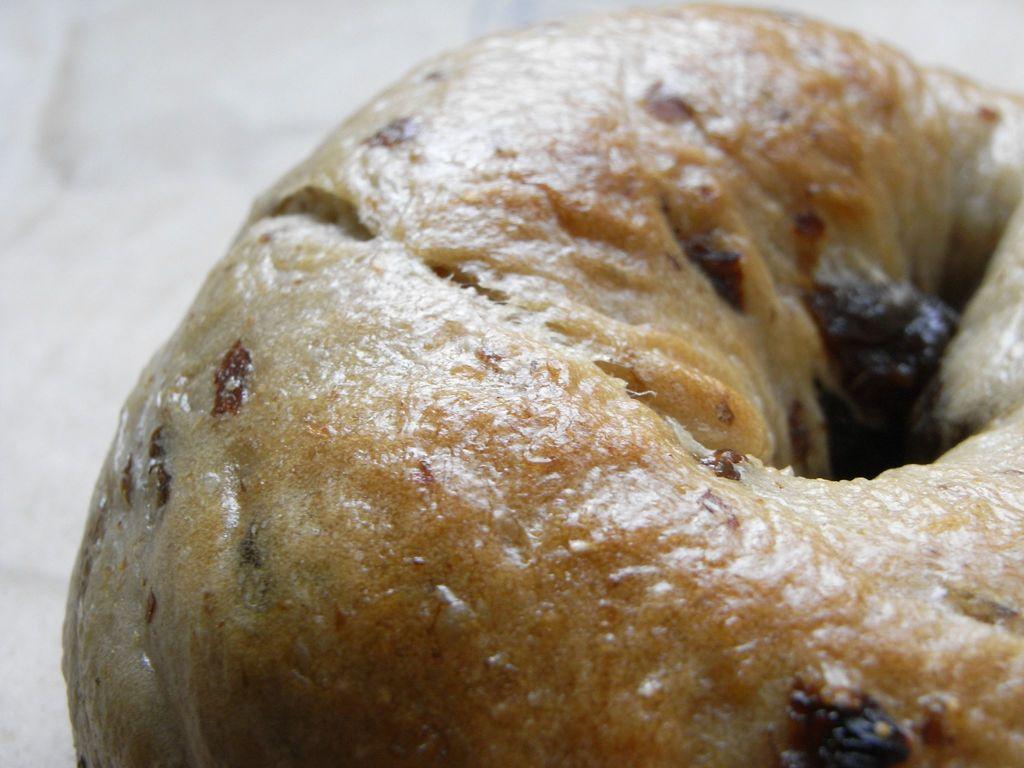Please provide a concise description of this image. In this image I can see a white colored surface and on the white colored surface I can see a food item which is brown in color. 